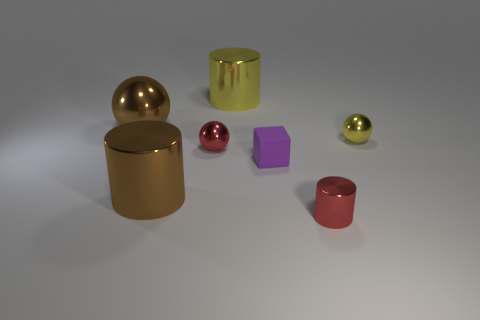Is there anything else that is made of the same material as the small purple block?
Provide a short and direct response. No. There is a large brown object that is in front of the small metallic sphere on the left side of the yellow sphere; how many big shiny objects are in front of it?
Your answer should be very brief. 0. There is a small yellow ball; how many yellow shiny things are left of it?
Offer a very short reply. 1. How many small objects are the same material as the brown ball?
Ensure brevity in your answer.  3. What color is the small cylinder that is the same material as the small yellow sphere?
Make the answer very short. Red. There is a big cylinder that is behind the yellow shiny thing right of the metal thing in front of the large brown shiny cylinder; what is it made of?
Give a very brief answer. Metal. Do the metallic thing in front of the brown cylinder and the large yellow object have the same size?
Your answer should be very brief. No. What number of tiny objects are metallic spheres or matte blocks?
Offer a terse response. 3. Are there any large cylinders of the same color as the tiny matte thing?
Offer a terse response. No. There is a purple thing that is the same size as the yellow sphere; what shape is it?
Keep it short and to the point. Cube. 